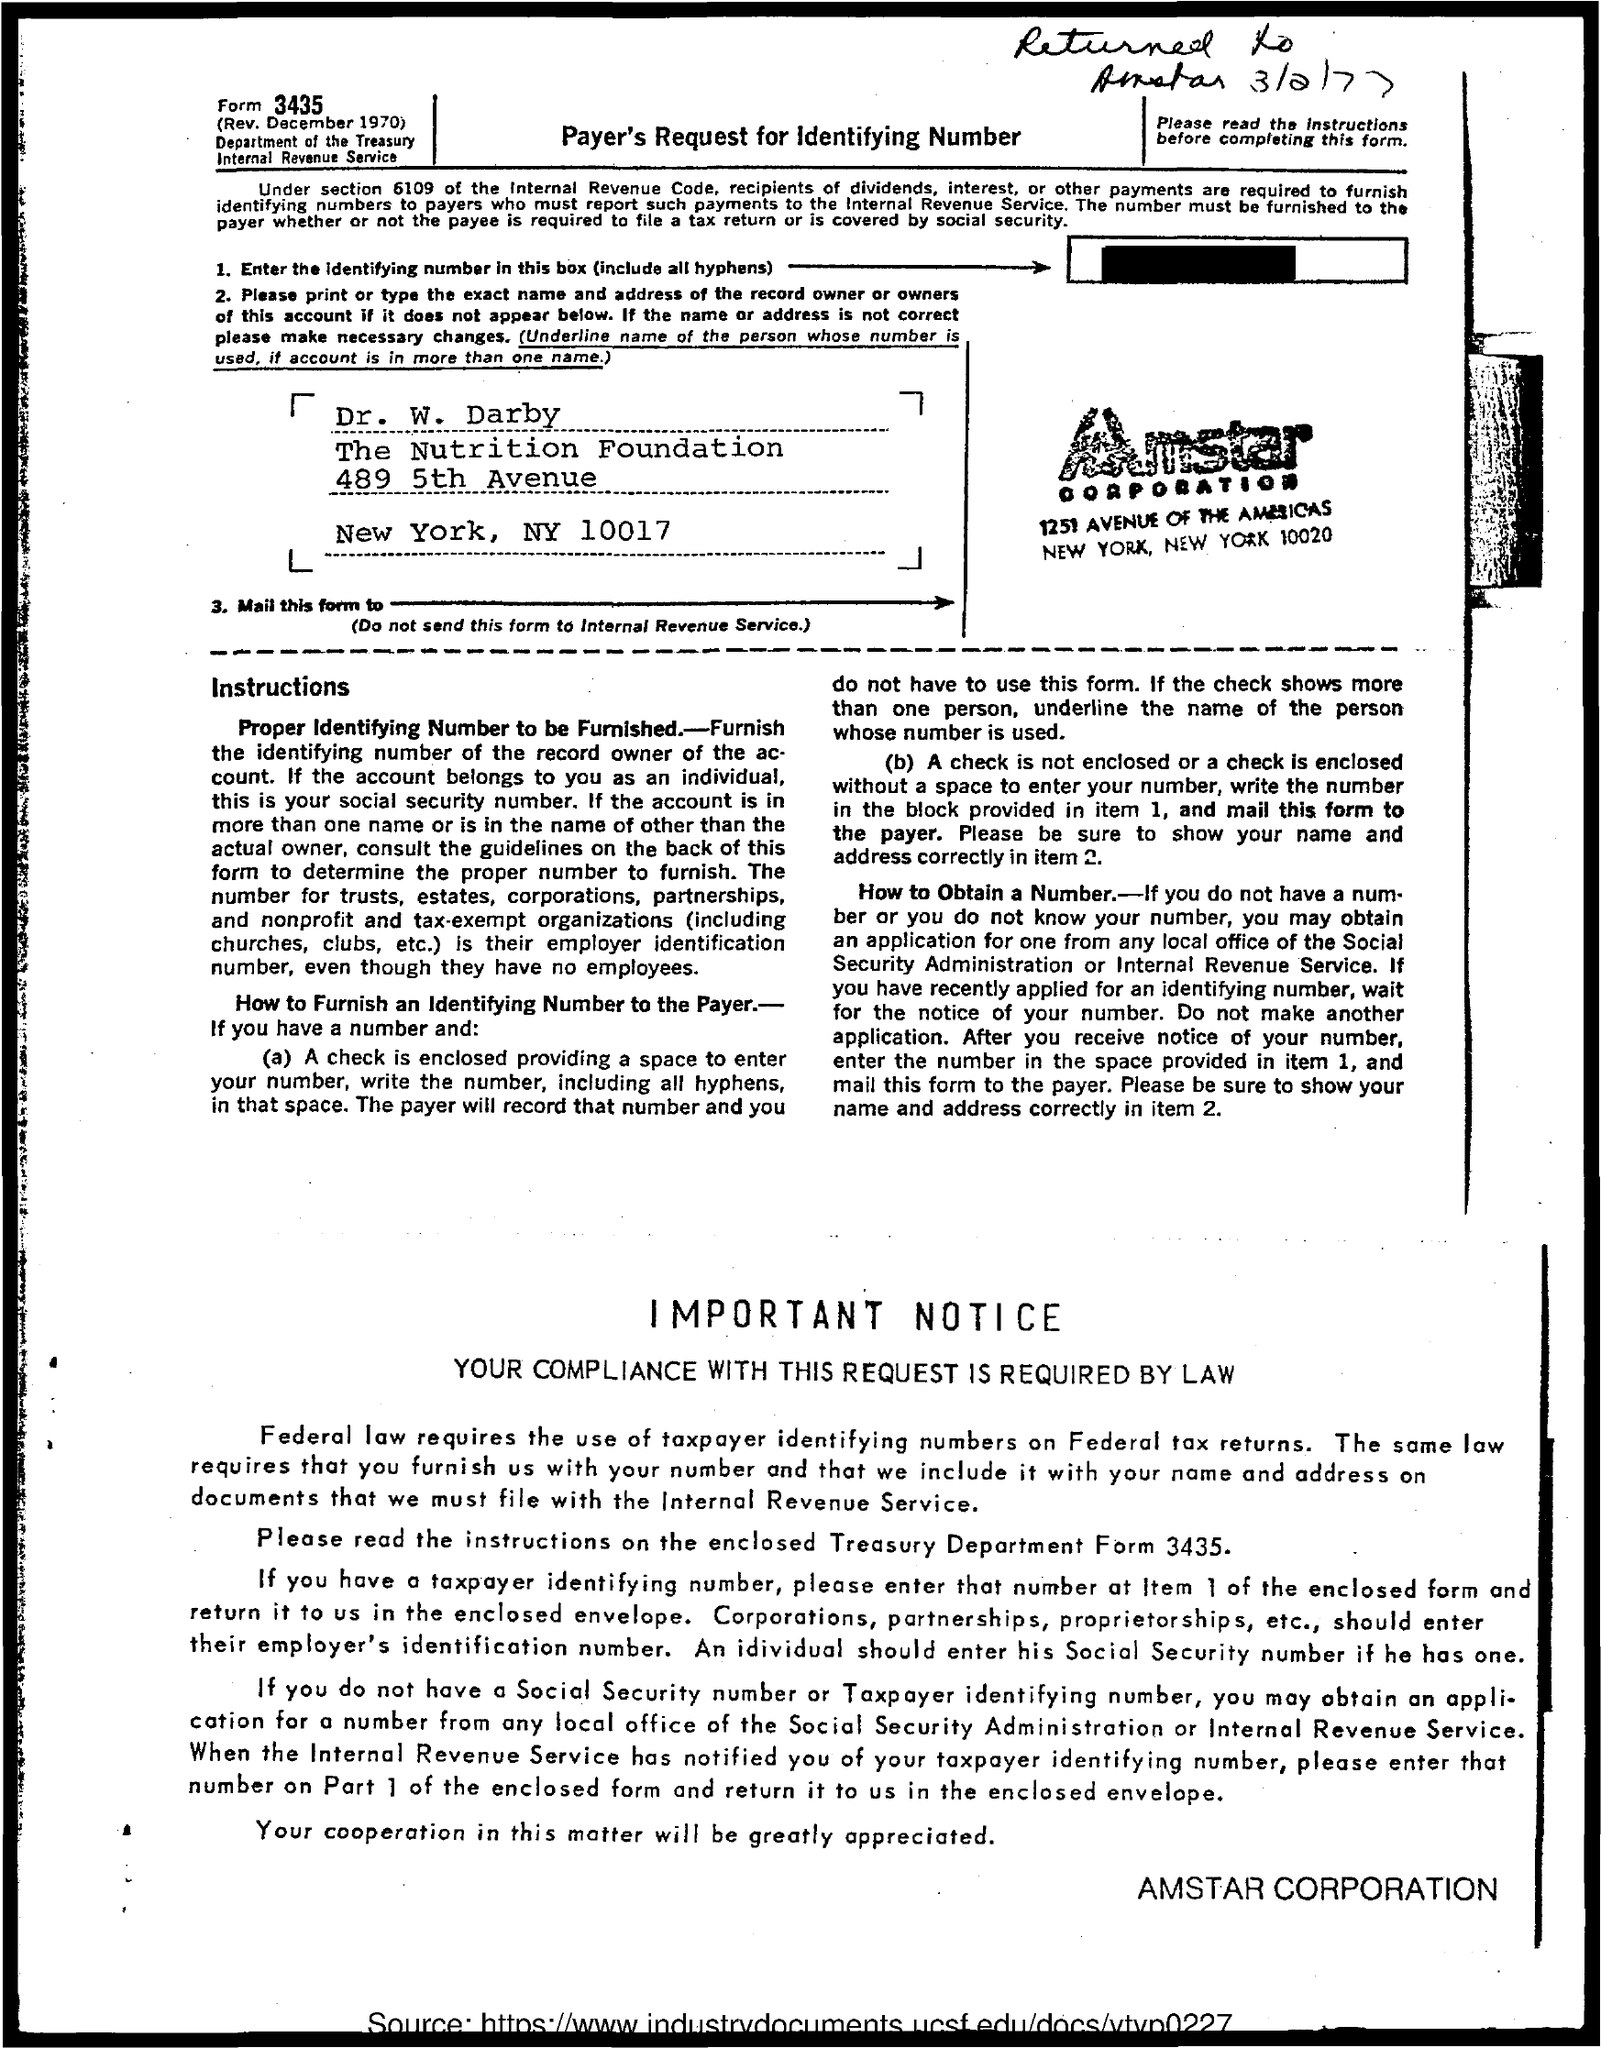What is the Form Number?
Give a very brief answer. 3435. What is the title of the document?
Offer a very short reply. Payer's Request for Identifying Number. What is the name of the Corporation?
Give a very brief answer. Amstar corporation. 